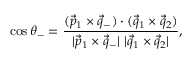Convert formula to latex. <formula><loc_0><loc_0><loc_500><loc_500>\cos \theta _ { - } = { \frac { ( \vec { p } _ { 1 } \times \vec { q } _ { - } ) \cdot ( \vec { q } _ { 1 } \times \vec { q } _ { 2 } ) } { | \vec { p } _ { 1 } \times \vec { q } _ { - } | \ | \vec { q } _ { 1 } \times \vec { q } _ { 2 } | } } ,</formula> 